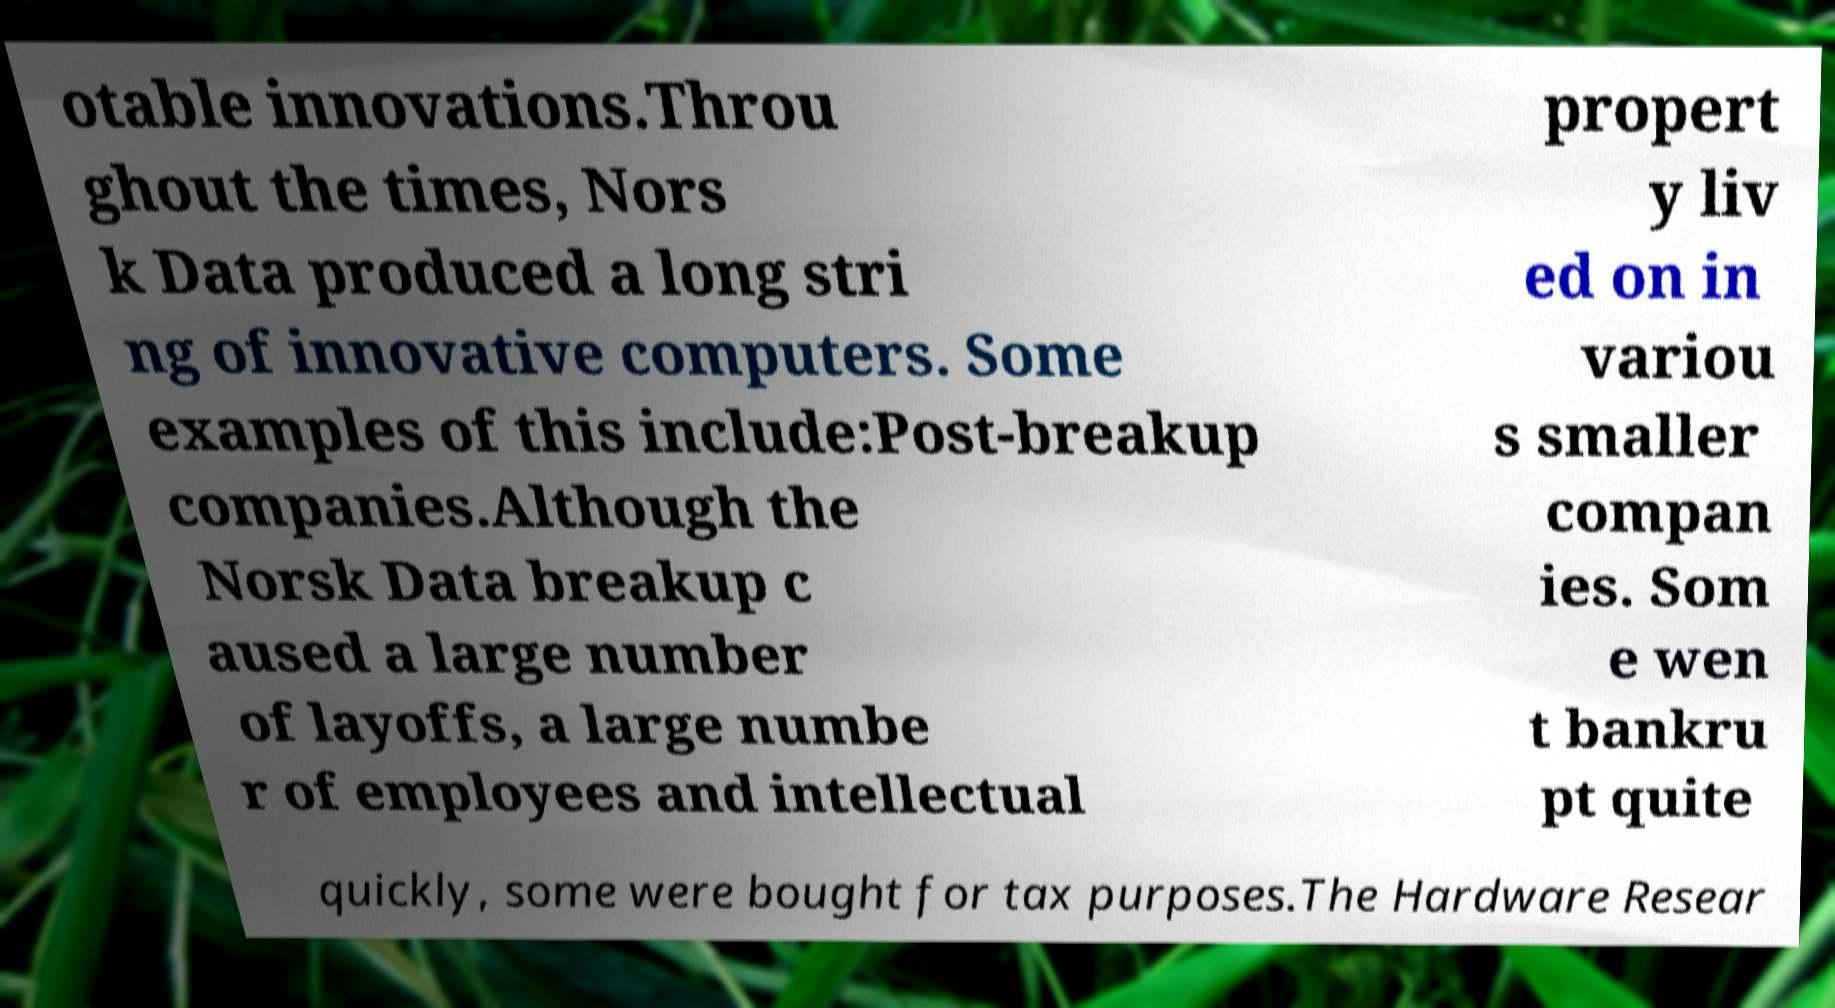Could you assist in decoding the text presented in this image and type it out clearly? otable innovations.Throu ghout the times, Nors k Data produced a long stri ng of innovative computers. Some examples of this include:Post-breakup companies.Although the Norsk Data breakup c aused a large number of layoffs, a large numbe r of employees and intellectual propert y liv ed on in variou s smaller compan ies. Som e wen t bankru pt quite quickly, some were bought for tax purposes.The Hardware Resear 